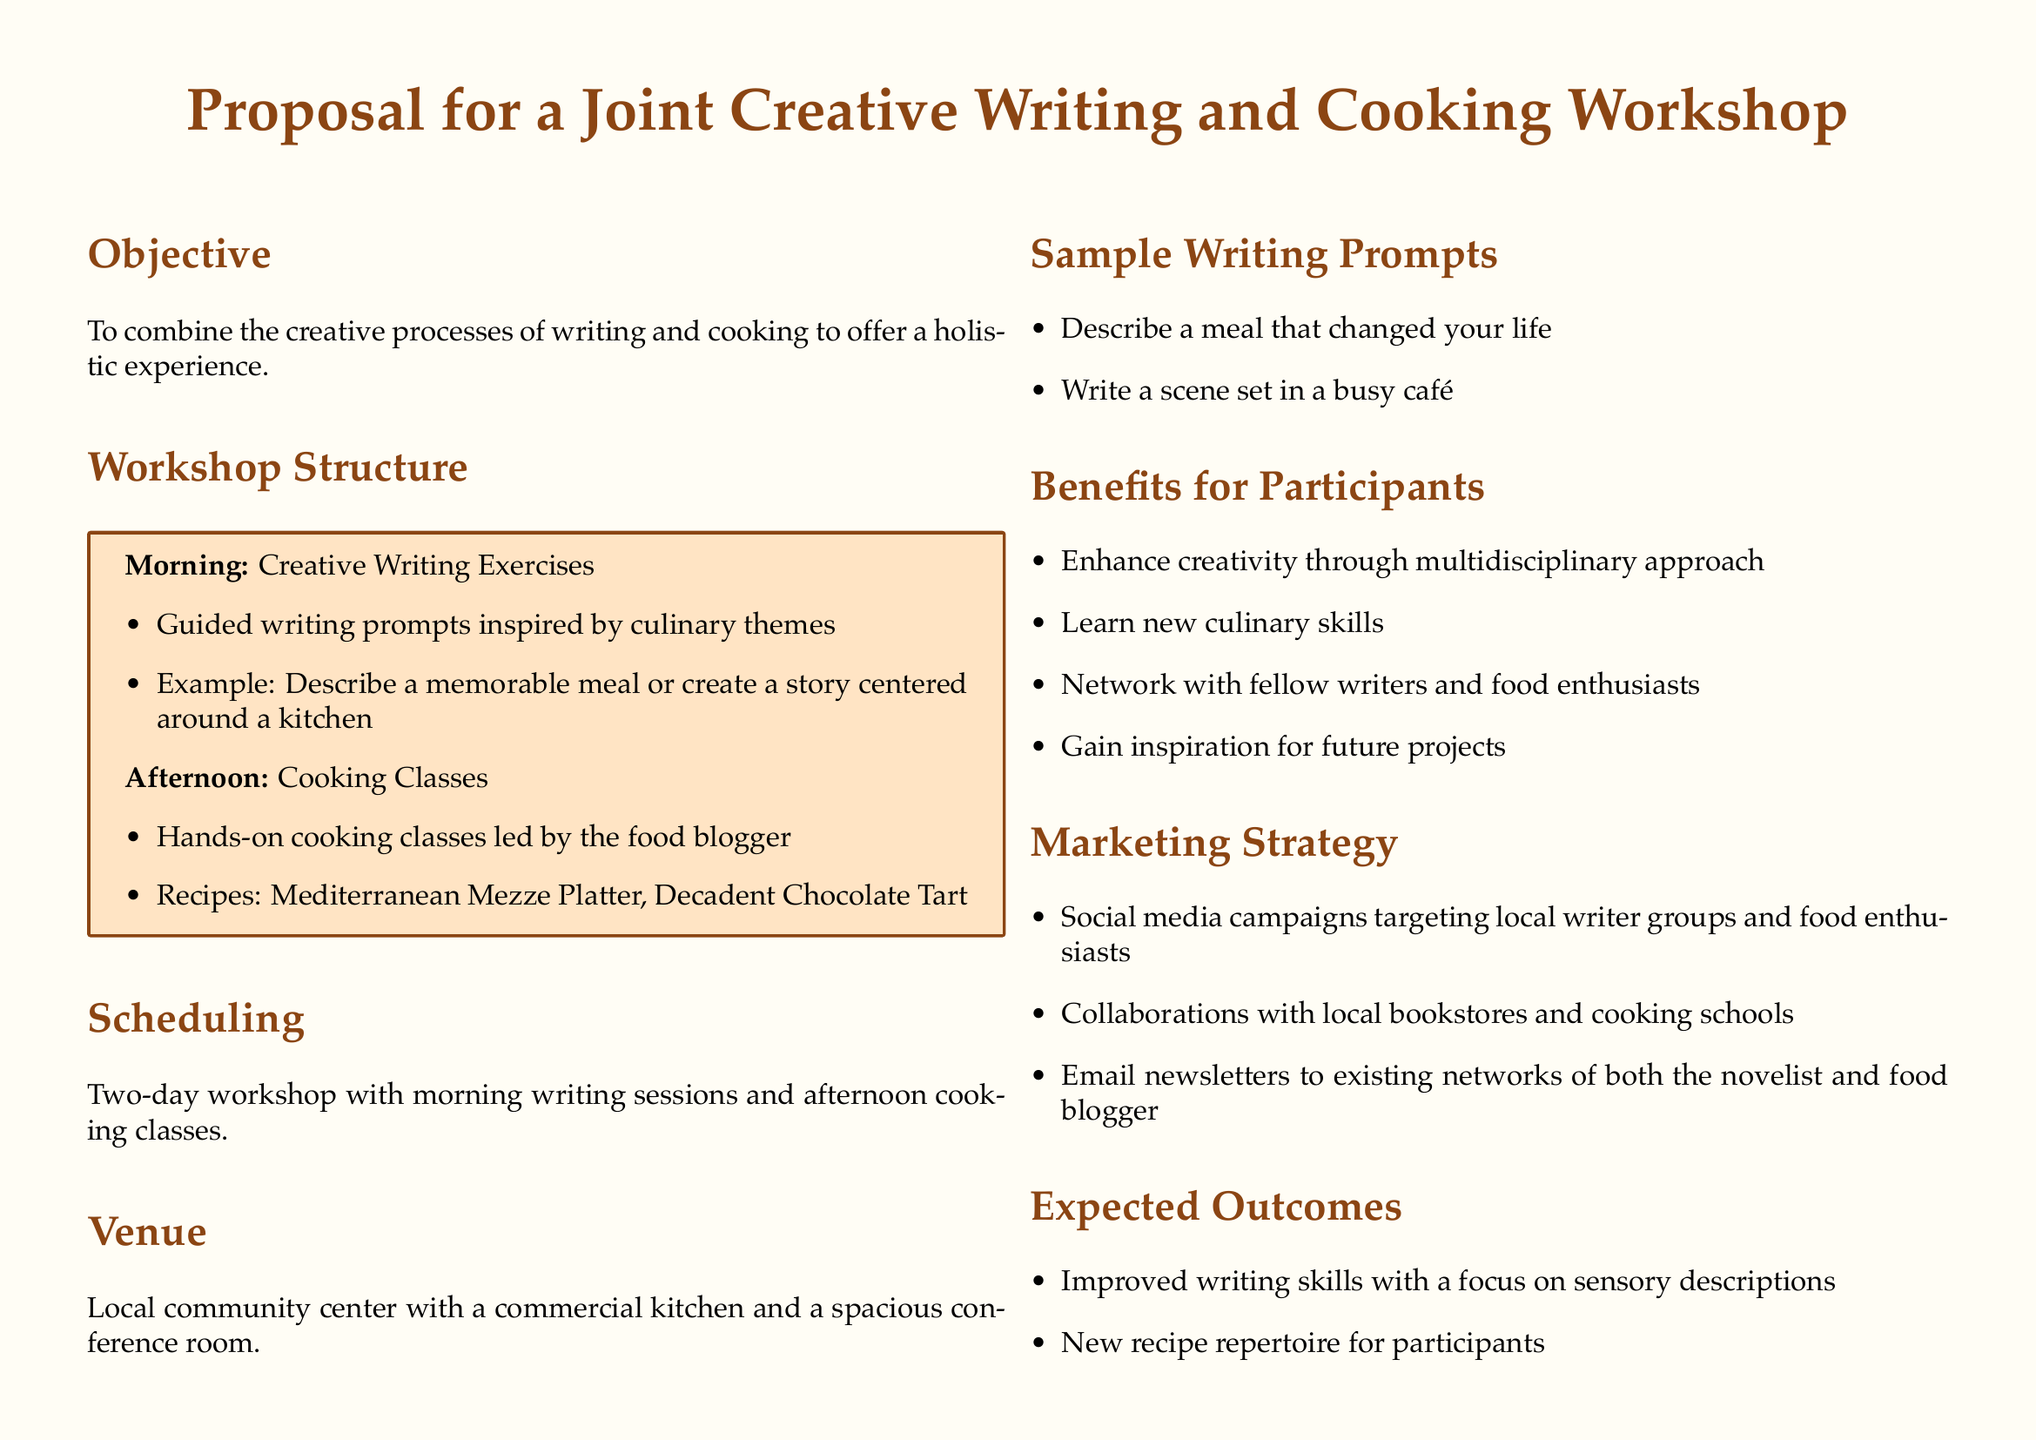What is the objective of the workshop? The objective is to combine the creative processes of writing and cooking to offer a holistic experience.
Answer: Combine the creative processes of writing and cooking How many days is the workshop scheduled for? The document specifies a two-day workshop.
Answer: Two days What type of dishes will be taught in the cooking class? The recipes mentioned are Mediterranean Mezze Platter and Decadent Chocolate Tart.
Answer: Mediterranean Mezze Platter, Decadent Chocolate Tart What venue is proposed for the workshop? The venue mentioned is a local community center with a commercial kitchen and a spacious conference room.
Answer: Local community center What is one benefit for participants? One benefit is enhanced creativity through a multidisciplinary approach.
Answer: Enhance creativity What marketing strategy involves local groups? Social media campaigns targeting local writer groups and food enthusiasts.
Answer: Social media campaigns What is a sample writing prompt given? An example of a sample writing prompt is to describe a meal that changed your life.
Answer: Describe a meal that changed your life What is expected as an outcome of the workshop? One expected outcome is improved writing skills focusing on sensory descriptions.
Answer: Improved writing skills How is the workshop structured in the morning session? The morning involves guided writing prompts inspired by culinary themes.
Answer: Guided writing prompts inspired by culinary themes 